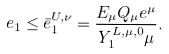<formula> <loc_0><loc_0><loc_500><loc_500>e _ { 1 } \leq \bar { e } _ { 1 } ^ { U , \nu } = \frac { E _ { \mu } Q _ { \mu } e ^ { \mu } } { Y _ { 1 } ^ { L , \mu , 0 } \mu } .</formula> 